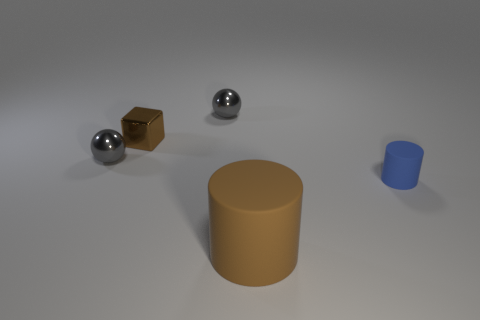Is there any other thing that has the same size as the brown matte object?
Offer a terse response. No. There is a matte cylinder that is in front of the small cylinder; does it have the same color as the tiny rubber cylinder that is on the right side of the small brown cube?
Your answer should be compact. No. What is the shape of the thing that is in front of the object on the right side of the big brown object?
Provide a succinct answer. Cylinder. Is there a blue rubber cylinder of the same size as the brown matte cylinder?
Offer a terse response. No. What number of other small blue matte objects are the same shape as the blue object?
Keep it short and to the point. 0. Are there an equal number of gray objects that are in front of the brown shiny cube and small shiny things right of the large brown thing?
Make the answer very short. No. Is there a large purple rubber cylinder?
Make the answer very short. No. How big is the gray metal thing that is on the left side of the small metallic ball behind the brown thing behind the large matte cylinder?
Your answer should be very brief. Small. The blue thing that is the same size as the brown shiny cube is what shape?
Your answer should be very brief. Cylinder. Is there anything else that is the same material as the tiny cylinder?
Keep it short and to the point. Yes. 